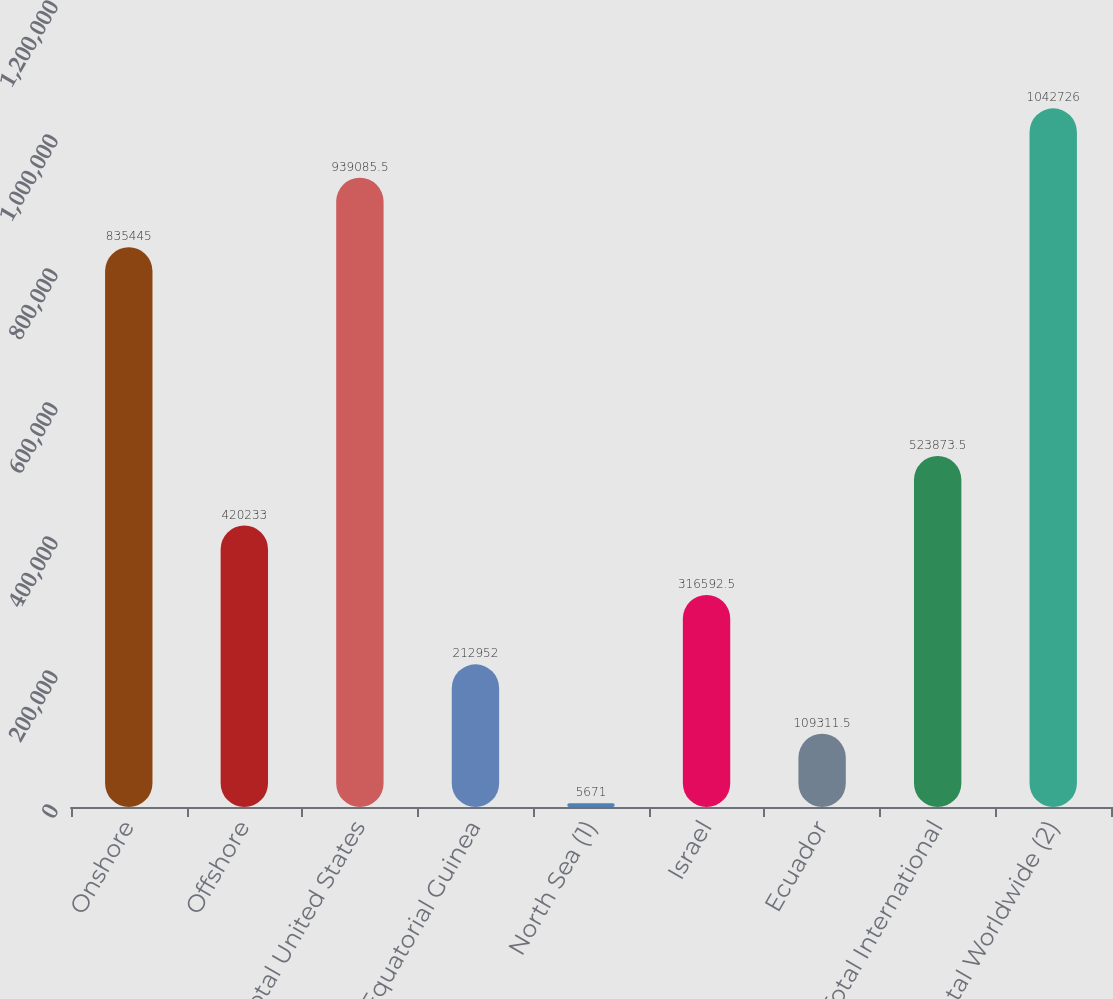Convert chart. <chart><loc_0><loc_0><loc_500><loc_500><bar_chart><fcel>Onshore<fcel>Offshore<fcel>Total United States<fcel>Equatorial Guinea<fcel>North Sea (1)<fcel>Israel<fcel>Ecuador<fcel>Total International<fcel>Total Worldwide (2)<nl><fcel>835445<fcel>420233<fcel>939086<fcel>212952<fcel>5671<fcel>316592<fcel>109312<fcel>523874<fcel>1.04273e+06<nl></chart> 